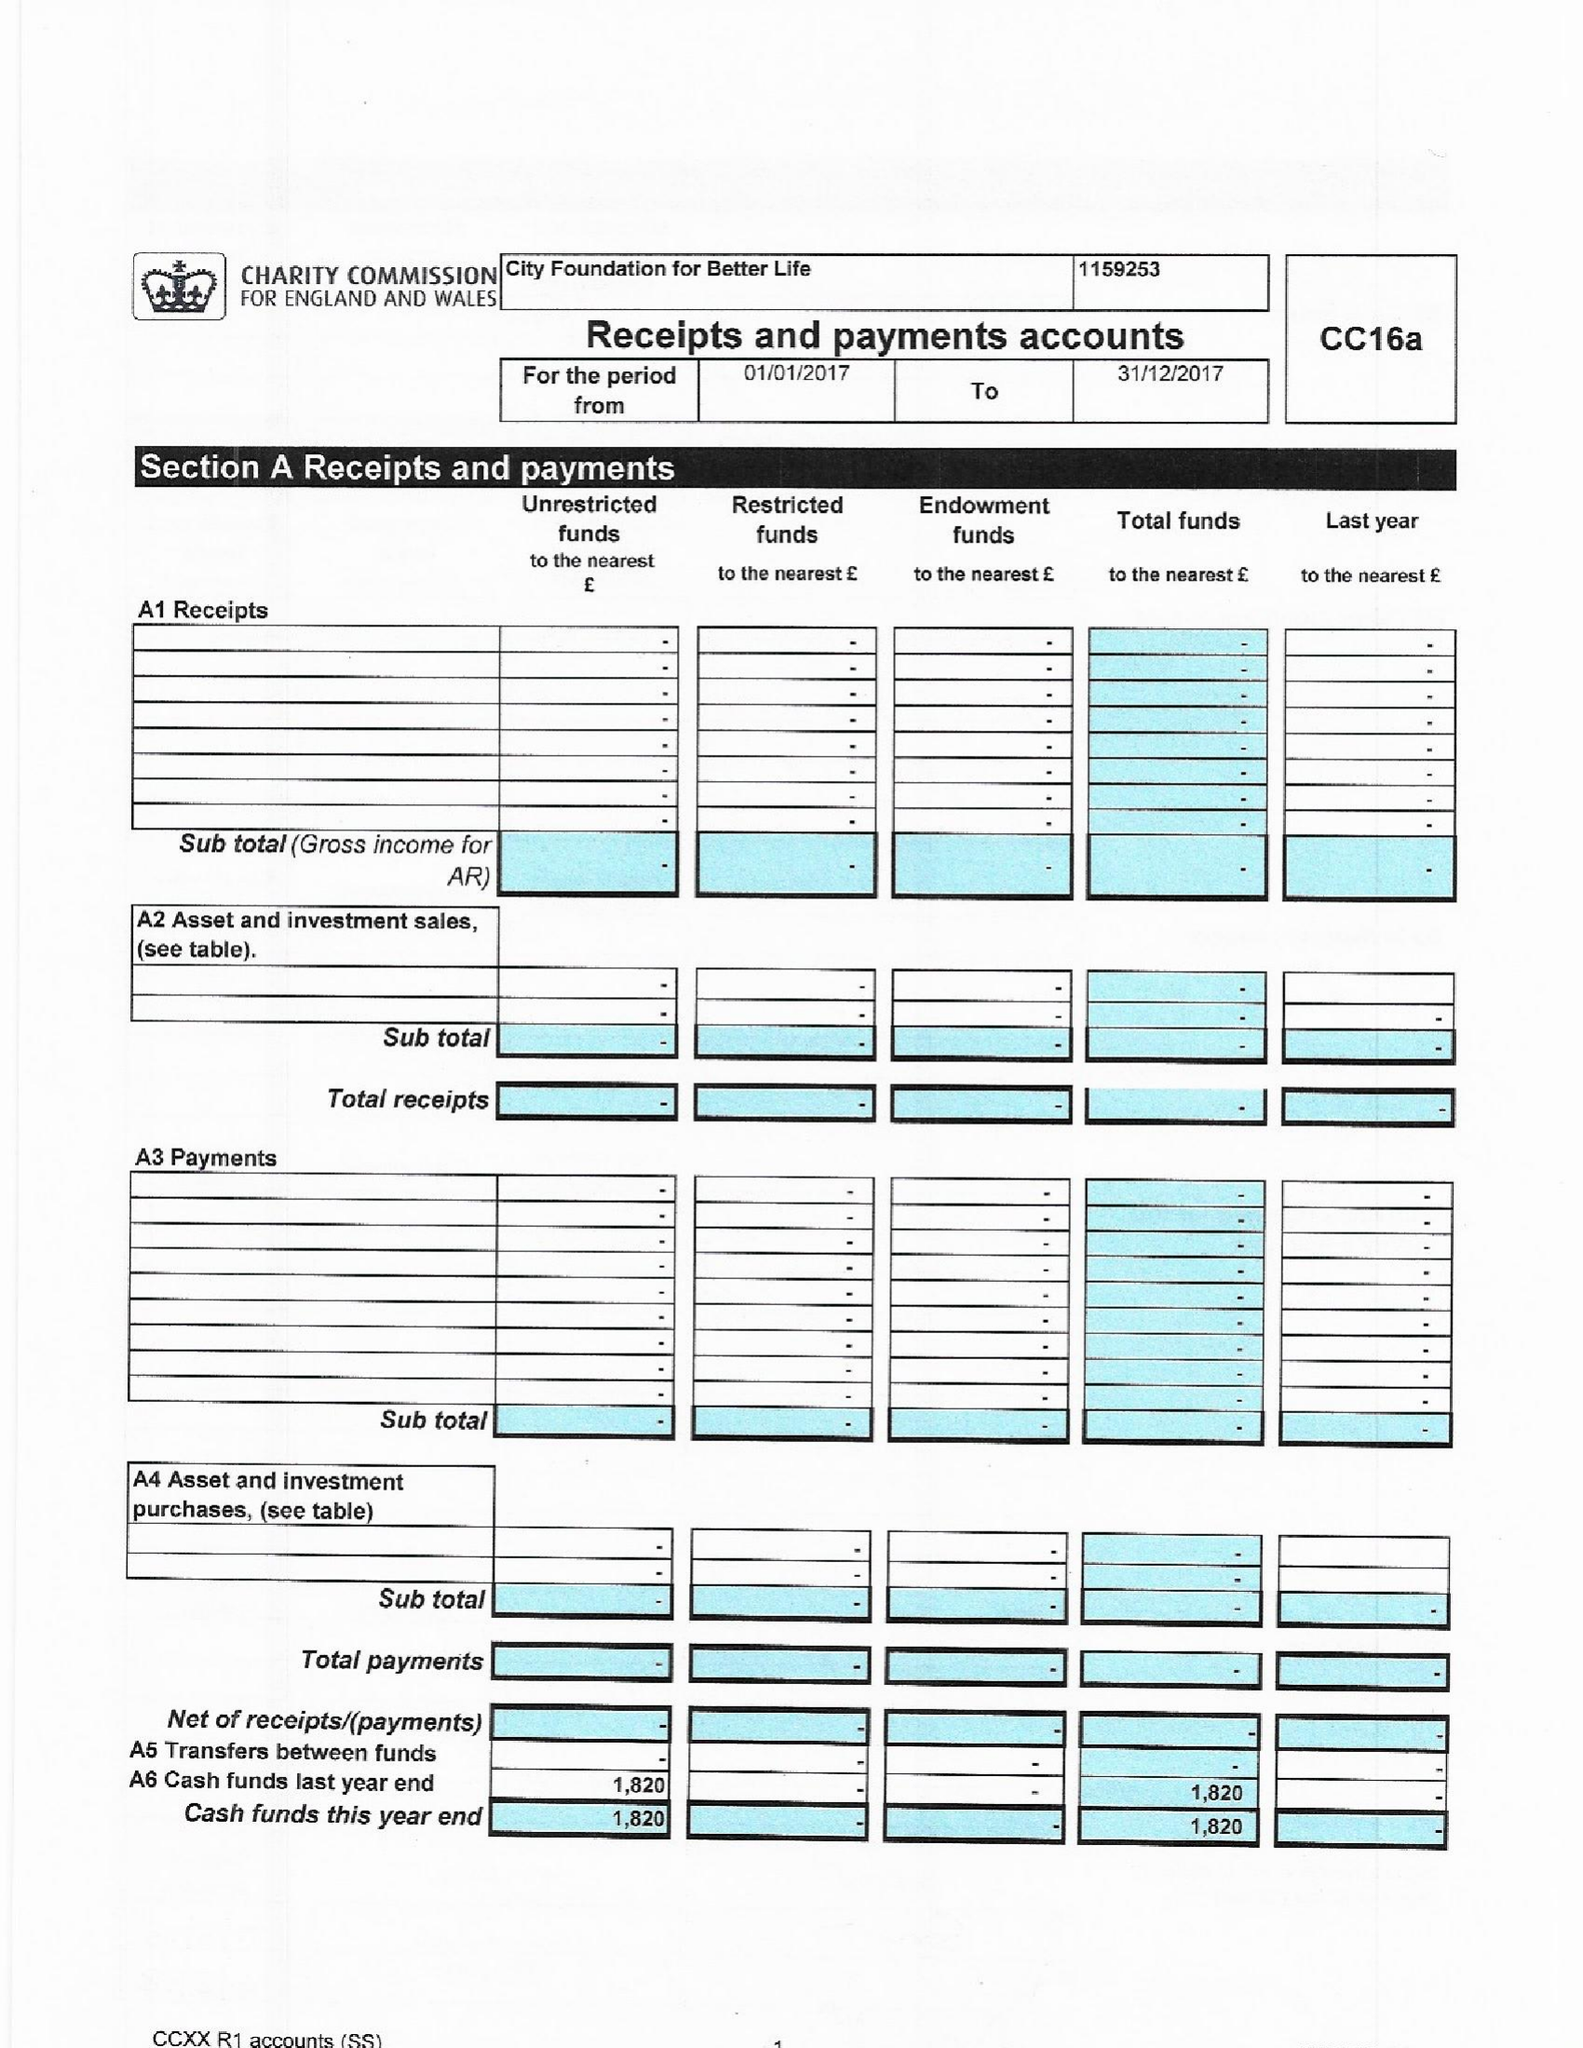What is the value for the spending_annually_in_british_pounds?
Answer the question using a single word or phrase. None 